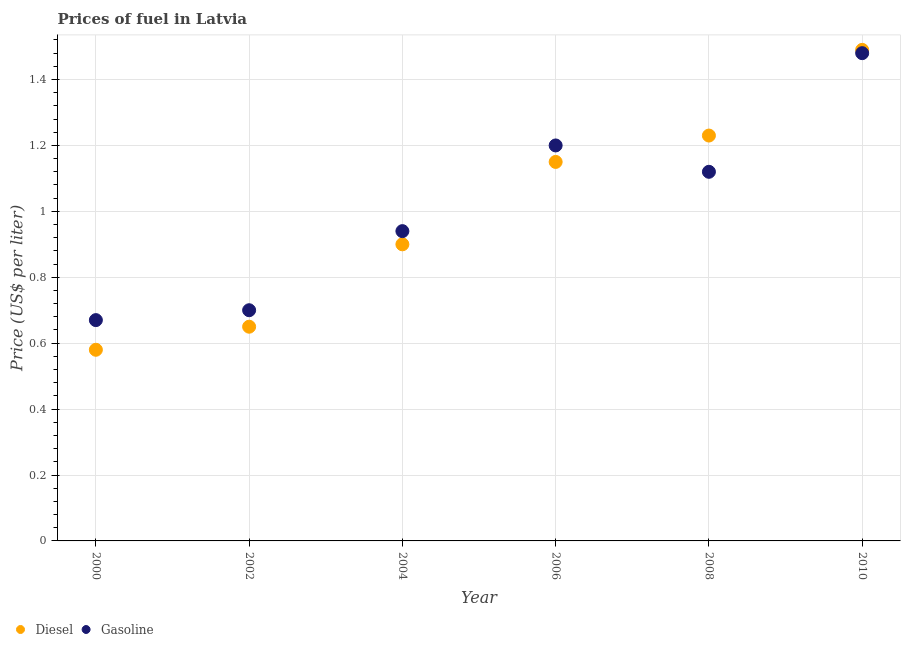What is the gasoline price in 2002?
Provide a succinct answer. 0.7. Across all years, what is the maximum gasoline price?
Provide a succinct answer. 1.48. Across all years, what is the minimum gasoline price?
Make the answer very short. 0.67. In which year was the gasoline price minimum?
Provide a short and direct response. 2000. What is the total gasoline price in the graph?
Keep it short and to the point. 6.11. What is the difference between the diesel price in 2000 and that in 2010?
Provide a short and direct response. -0.91. What is the difference between the diesel price in 2010 and the gasoline price in 2006?
Provide a succinct answer. 0.29. What is the average gasoline price per year?
Your response must be concise. 1.02. In the year 2004, what is the difference between the gasoline price and diesel price?
Your answer should be compact. 0.04. In how many years, is the gasoline price greater than 0.08 US$ per litre?
Your response must be concise. 6. What is the ratio of the diesel price in 2002 to that in 2004?
Give a very brief answer. 0.72. Is the diesel price in 2000 less than that in 2008?
Your answer should be very brief. Yes. What is the difference between the highest and the second highest gasoline price?
Provide a short and direct response. 0.28. What is the difference between the highest and the lowest diesel price?
Give a very brief answer. 0.91. In how many years, is the diesel price greater than the average diesel price taken over all years?
Provide a short and direct response. 3. Is the sum of the diesel price in 2008 and 2010 greater than the maximum gasoline price across all years?
Offer a terse response. Yes. Is the gasoline price strictly less than the diesel price over the years?
Give a very brief answer. No. How many years are there in the graph?
Offer a very short reply. 6. What is the difference between two consecutive major ticks on the Y-axis?
Ensure brevity in your answer.  0.2. Does the graph contain any zero values?
Give a very brief answer. No. How many legend labels are there?
Make the answer very short. 2. How are the legend labels stacked?
Offer a terse response. Horizontal. What is the title of the graph?
Give a very brief answer. Prices of fuel in Latvia. Does "constant 2005 US$" appear as one of the legend labels in the graph?
Offer a very short reply. No. What is the label or title of the Y-axis?
Provide a succinct answer. Price (US$ per liter). What is the Price (US$ per liter) of Diesel in 2000?
Provide a short and direct response. 0.58. What is the Price (US$ per liter) of Gasoline in 2000?
Ensure brevity in your answer.  0.67. What is the Price (US$ per liter) of Diesel in 2002?
Your response must be concise. 0.65. What is the Price (US$ per liter) of Diesel in 2004?
Provide a succinct answer. 0.9. What is the Price (US$ per liter) in Diesel in 2006?
Ensure brevity in your answer.  1.15. What is the Price (US$ per liter) of Diesel in 2008?
Offer a very short reply. 1.23. What is the Price (US$ per liter) of Gasoline in 2008?
Your answer should be very brief. 1.12. What is the Price (US$ per liter) of Diesel in 2010?
Keep it short and to the point. 1.49. What is the Price (US$ per liter) in Gasoline in 2010?
Keep it short and to the point. 1.48. Across all years, what is the maximum Price (US$ per liter) in Diesel?
Your response must be concise. 1.49. Across all years, what is the maximum Price (US$ per liter) of Gasoline?
Make the answer very short. 1.48. Across all years, what is the minimum Price (US$ per liter) in Diesel?
Your answer should be very brief. 0.58. Across all years, what is the minimum Price (US$ per liter) of Gasoline?
Ensure brevity in your answer.  0.67. What is the total Price (US$ per liter) of Diesel in the graph?
Make the answer very short. 6. What is the total Price (US$ per liter) in Gasoline in the graph?
Your response must be concise. 6.11. What is the difference between the Price (US$ per liter) of Diesel in 2000 and that in 2002?
Your response must be concise. -0.07. What is the difference between the Price (US$ per liter) in Gasoline in 2000 and that in 2002?
Give a very brief answer. -0.03. What is the difference between the Price (US$ per liter) in Diesel in 2000 and that in 2004?
Your answer should be compact. -0.32. What is the difference between the Price (US$ per liter) in Gasoline in 2000 and that in 2004?
Your response must be concise. -0.27. What is the difference between the Price (US$ per liter) of Diesel in 2000 and that in 2006?
Provide a succinct answer. -0.57. What is the difference between the Price (US$ per liter) of Gasoline in 2000 and that in 2006?
Ensure brevity in your answer.  -0.53. What is the difference between the Price (US$ per liter) of Diesel in 2000 and that in 2008?
Make the answer very short. -0.65. What is the difference between the Price (US$ per liter) in Gasoline in 2000 and that in 2008?
Your answer should be compact. -0.45. What is the difference between the Price (US$ per liter) of Diesel in 2000 and that in 2010?
Ensure brevity in your answer.  -0.91. What is the difference between the Price (US$ per liter) of Gasoline in 2000 and that in 2010?
Ensure brevity in your answer.  -0.81. What is the difference between the Price (US$ per liter) in Gasoline in 2002 and that in 2004?
Your response must be concise. -0.24. What is the difference between the Price (US$ per liter) in Diesel in 2002 and that in 2006?
Give a very brief answer. -0.5. What is the difference between the Price (US$ per liter) in Gasoline in 2002 and that in 2006?
Ensure brevity in your answer.  -0.5. What is the difference between the Price (US$ per liter) in Diesel in 2002 and that in 2008?
Offer a terse response. -0.58. What is the difference between the Price (US$ per liter) of Gasoline in 2002 and that in 2008?
Offer a terse response. -0.42. What is the difference between the Price (US$ per liter) in Diesel in 2002 and that in 2010?
Offer a terse response. -0.84. What is the difference between the Price (US$ per liter) of Gasoline in 2002 and that in 2010?
Offer a terse response. -0.78. What is the difference between the Price (US$ per liter) of Gasoline in 2004 and that in 2006?
Keep it short and to the point. -0.26. What is the difference between the Price (US$ per liter) of Diesel in 2004 and that in 2008?
Keep it short and to the point. -0.33. What is the difference between the Price (US$ per liter) of Gasoline in 2004 and that in 2008?
Your answer should be compact. -0.18. What is the difference between the Price (US$ per liter) of Diesel in 2004 and that in 2010?
Ensure brevity in your answer.  -0.59. What is the difference between the Price (US$ per liter) of Gasoline in 2004 and that in 2010?
Your answer should be very brief. -0.54. What is the difference between the Price (US$ per liter) of Diesel in 2006 and that in 2008?
Keep it short and to the point. -0.08. What is the difference between the Price (US$ per liter) in Diesel in 2006 and that in 2010?
Ensure brevity in your answer.  -0.34. What is the difference between the Price (US$ per liter) in Gasoline in 2006 and that in 2010?
Offer a terse response. -0.28. What is the difference between the Price (US$ per liter) in Diesel in 2008 and that in 2010?
Give a very brief answer. -0.26. What is the difference between the Price (US$ per liter) of Gasoline in 2008 and that in 2010?
Your answer should be very brief. -0.36. What is the difference between the Price (US$ per liter) in Diesel in 2000 and the Price (US$ per liter) in Gasoline in 2002?
Keep it short and to the point. -0.12. What is the difference between the Price (US$ per liter) in Diesel in 2000 and the Price (US$ per liter) in Gasoline in 2004?
Your answer should be very brief. -0.36. What is the difference between the Price (US$ per liter) in Diesel in 2000 and the Price (US$ per liter) in Gasoline in 2006?
Provide a short and direct response. -0.62. What is the difference between the Price (US$ per liter) of Diesel in 2000 and the Price (US$ per liter) of Gasoline in 2008?
Give a very brief answer. -0.54. What is the difference between the Price (US$ per liter) in Diesel in 2002 and the Price (US$ per liter) in Gasoline in 2004?
Your answer should be very brief. -0.29. What is the difference between the Price (US$ per liter) in Diesel in 2002 and the Price (US$ per liter) in Gasoline in 2006?
Provide a succinct answer. -0.55. What is the difference between the Price (US$ per liter) in Diesel in 2002 and the Price (US$ per liter) in Gasoline in 2008?
Offer a very short reply. -0.47. What is the difference between the Price (US$ per liter) of Diesel in 2002 and the Price (US$ per liter) of Gasoline in 2010?
Keep it short and to the point. -0.83. What is the difference between the Price (US$ per liter) of Diesel in 2004 and the Price (US$ per liter) of Gasoline in 2008?
Provide a succinct answer. -0.22. What is the difference between the Price (US$ per liter) of Diesel in 2004 and the Price (US$ per liter) of Gasoline in 2010?
Make the answer very short. -0.58. What is the difference between the Price (US$ per liter) of Diesel in 2006 and the Price (US$ per liter) of Gasoline in 2010?
Offer a terse response. -0.33. What is the average Price (US$ per liter) in Diesel per year?
Keep it short and to the point. 1. What is the average Price (US$ per liter) in Gasoline per year?
Your response must be concise. 1.02. In the year 2000, what is the difference between the Price (US$ per liter) of Diesel and Price (US$ per liter) of Gasoline?
Provide a succinct answer. -0.09. In the year 2004, what is the difference between the Price (US$ per liter) in Diesel and Price (US$ per liter) in Gasoline?
Ensure brevity in your answer.  -0.04. In the year 2008, what is the difference between the Price (US$ per liter) in Diesel and Price (US$ per liter) in Gasoline?
Give a very brief answer. 0.11. In the year 2010, what is the difference between the Price (US$ per liter) of Diesel and Price (US$ per liter) of Gasoline?
Make the answer very short. 0.01. What is the ratio of the Price (US$ per liter) of Diesel in 2000 to that in 2002?
Give a very brief answer. 0.89. What is the ratio of the Price (US$ per liter) of Gasoline in 2000 to that in 2002?
Provide a succinct answer. 0.96. What is the ratio of the Price (US$ per liter) of Diesel in 2000 to that in 2004?
Your response must be concise. 0.64. What is the ratio of the Price (US$ per liter) of Gasoline in 2000 to that in 2004?
Give a very brief answer. 0.71. What is the ratio of the Price (US$ per liter) of Diesel in 2000 to that in 2006?
Offer a very short reply. 0.5. What is the ratio of the Price (US$ per liter) of Gasoline in 2000 to that in 2006?
Keep it short and to the point. 0.56. What is the ratio of the Price (US$ per liter) of Diesel in 2000 to that in 2008?
Provide a succinct answer. 0.47. What is the ratio of the Price (US$ per liter) of Gasoline in 2000 to that in 2008?
Your answer should be very brief. 0.6. What is the ratio of the Price (US$ per liter) of Diesel in 2000 to that in 2010?
Keep it short and to the point. 0.39. What is the ratio of the Price (US$ per liter) of Gasoline in 2000 to that in 2010?
Your answer should be compact. 0.45. What is the ratio of the Price (US$ per liter) in Diesel in 2002 to that in 2004?
Your answer should be compact. 0.72. What is the ratio of the Price (US$ per liter) of Gasoline in 2002 to that in 2004?
Your answer should be compact. 0.74. What is the ratio of the Price (US$ per liter) in Diesel in 2002 to that in 2006?
Your answer should be compact. 0.57. What is the ratio of the Price (US$ per liter) in Gasoline in 2002 to that in 2006?
Your answer should be very brief. 0.58. What is the ratio of the Price (US$ per liter) of Diesel in 2002 to that in 2008?
Ensure brevity in your answer.  0.53. What is the ratio of the Price (US$ per liter) in Diesel in 2002 to that in 2010?
Offer a terse response. 0.44. What is the ratio of the Price (US$ per liter) in Gasoline in 2002 to that in 2010?
Make the answer very short. 0.47. What is the ratio of the Price (US$ per liter) in Diesel in 2004 to that in 2006?
Offer a very short reply. 0.78. What is the ratio of the Price (US$ per liter) of Gasoline in 2004 to that in 2006?
Give a very brief answer. 0.78. What is the ratio of the Price (US$ per liter) of Diesel in 2004 to that in 2008?
Ensure brevity in your answer.  0.73. What is the ratio of the Price (US$ per liter) in Gasoline in 2004 to that in 2008?
Your answer should be very brief. 0.84. What is the ratio of the Price (US$ per liter) of Diesel in 2004 to that in 2010?
Keep it short and to the point. 0.6. What is the ratio of the Price (US$ per liter) of Gasoline in 2004 to that in 2010?
Offer a very short reply. 0.64. What is the ratio of the Price (US$ per liter) in Diesel in 2006 to that in 2008?
Keep it short and to the point. 0.94. What is the ratio of the Price (US$ per liter) in Gasoline in 2006 to that in 2008?
Your answer should be very brief. 1.07. What is the ratio of the Price (US$ per liter) in Diesel in 2006 to that in 2010?
Ensure brevity in your answer.  0.77. What is the ratio of the Price (US$ per liter) in Gasoline in 2006 to that in 2010?
Your response must be concise. 0.81. What is the ratio of the Price (US$ per liter) in Diesel in 2008 to that in 2010?
Keep it short and to the point. 0.83. What is the ratio of the Price (US$ per liter) in Gasoline in 2008 to that in 2010?
Give a very brief answer. 0.76. What is the difference between the highest and the second highest Price (US$ per liter) in Diesel?
Keep it short and to the point. 0.26. What is the difference between the highest and the second highest Price (US$ per liter) of Gasoline?
Provide a succinct answer. 0.28. What is the difference between the highest and the lowest Price (US$ per liter) in Diesel?
Your answer should be compact. 0.91. What is the difference between the highest and the lowest Price (US$ per liter) in Gasoline?
Your answer should be compact. 0.81. 